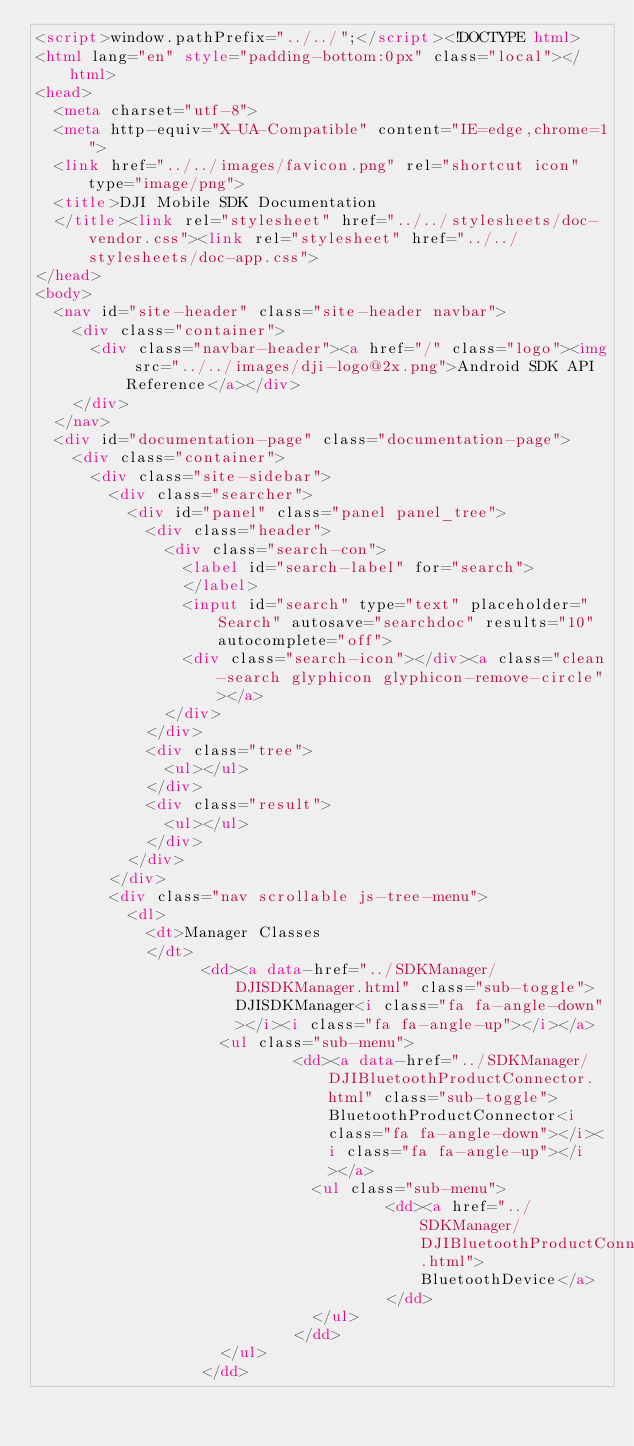<code> <loc_0><loc_0><loc_500><loc_500><_HTML_><script>window.pathPrefix="../../";</script><!DOCTYPE html>
<html lang="en" style="padding-bottom:0px" class="local"></html>
<head>
  <meta charset="utf-8">
  <meta http-equiv="X-UA-Compatible" content="IE=edge,chrome=1">
  <link href="../../images/favicon.png" rel="shortcut icon" type="image/png">
  <title>DJI Mobile SDK Documentation
  </title><link rel="stylesheet" href="../../stylesheets/doc-vendor.css"><link rel="stylesheet" href="../../stylesheets/doc-app.css">
</head>
<body>
  <nav id="site-header" class="site-header navbar">
    <div class="container">
      <div class="navbar-header"><a href="/" class="logo"><img src="../../images/dji-logo@2x.png">Android SDK API Reference</a></div>
    </div>
  </nav>
  <div id="documentation-page" class="documentation-page">
    <div class="container">
      <div class="site-sidebar">
        <div class="searcher">
          <div id="panel" class="panel panel_tree">
            <div class="header">
              <div class="search-con">
                <label id="search-label" for="search">
                </label>
                <input id="search" type="text" placeholder="Search" autosave="searchdoc" results="10" autocomplete="off">
                <div class="search-icon"></div><a class="clean-search glyphicon glyphicon-remove-circle"></a>
              </div>
            </div>
            <div class="tree">
              <ul></ul>
            </div>
            <div class="result">
              <ul></ul>
            </div>
          </div>
        </div>
        <div class="nav scrollable js-tree-menu">
          <dl>
            <dt>Manager Classes
            </dt>
                  <dd><a data-href="../SDKManager/DJISDKManager.html" class="sub-toggle">DJISDKManager<i class="fa fa-angle-down"></i><i class="fa fa-angle-up"></i></a>
                    <ul class="sub-menu">
                            <dd><a data-href="../SDKManager/DJIBluetoothProductConnector.html" class="sub-toggle">BluetoothProductConnector<i class="fa fa-angle-down"></i><i class="fa fa-angle-up"></i></a>
                              <ul class="sub-menu">
                                      <dd><a href="../SDKManager/DJIBluetoothProductConnector_DJIBluetoothDevice.html">BluetoothDevice</a>
                                      </dd>
                              </ul>
                            </dd>
                    </ul>
                  </dd></code> 